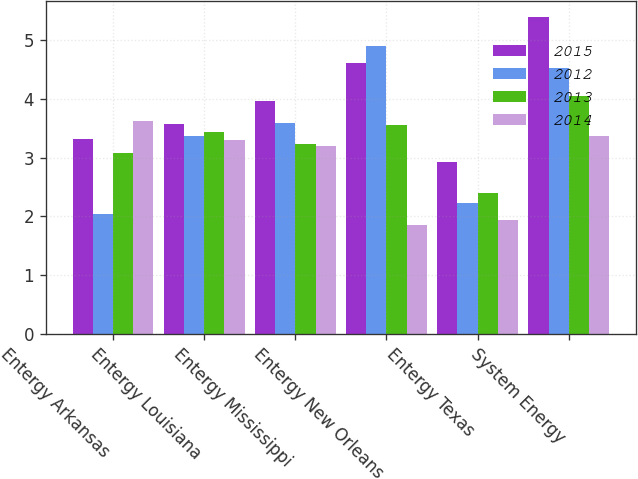<chart> <loc_0><loc_0><loc_500><loc_500><stacked_bar_chart><ecel><fcel>Entergy Arkansas<fcel>Entergy Louisiana<fcel>Entergy Mississippi<fcel>Entergy New Orleans<fcel>Entergy Texas<fcel>System Energy<nl><fcel>2015<fcel>3.32<fcel>3.57<fcel>3.96<fcel>4.61<fcel>2.92<fcel>5.39<nl><fcel>2012<fcel>2.04<fcel>3.36<fcel>3.59<fcel>4.9<fcel>2.22<fcel>4.53<nl><fcel>2013<fcel>3.08<fcel>3.44<fcel>3.23<fcel>3.55<fcel>2.39<fcel>4.04<nl><fcel>2014<fcel>3.62<fcel>3.3<fcel>3.19<fcel>1.85<fcel>1.94<fcel>3.36<nl></chart> 